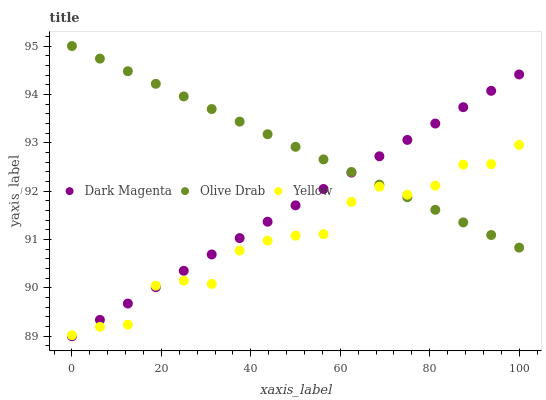Does Yellow have the minimum area under the curve?
Answer yes or no. Yes. Does Olive Drab have the maximum area under the curve?
Answer yes or no. Yes. Does Dark Magenta have the minimum area under the curve?
Answer yes or no. No. Does Dark Magenta have the maximum area under the curve?
Answer yes or no. No. Is Dark Magenta the smoothest?
Answer yes or no. Yes. Is Yellow the roughest?
Answer yes or no. Yes. Is Olive Drab the smoothest?
Answer yes or no. No. Is Olive Drab the roughest?
Answer yes or no. No. Does Dark Magenta have the lowest value?
Answer yes or no. Yes. Does Olive Drab have the lowest value?
Answer yes or no. No. Does Olive Drab have the highest value?
Answer yes or no. Yes. Does Dark Magenta have the highest value?
Answer yes or no. No. Does Dark Magenta intersect Olive Drab?
Answer yes or no. Yes. Is Dark Magenta less than Olive Drab?
Answer yes or no. No. Is Dark Magenta greater than Olive Drab?
Answer yes or no. No. 